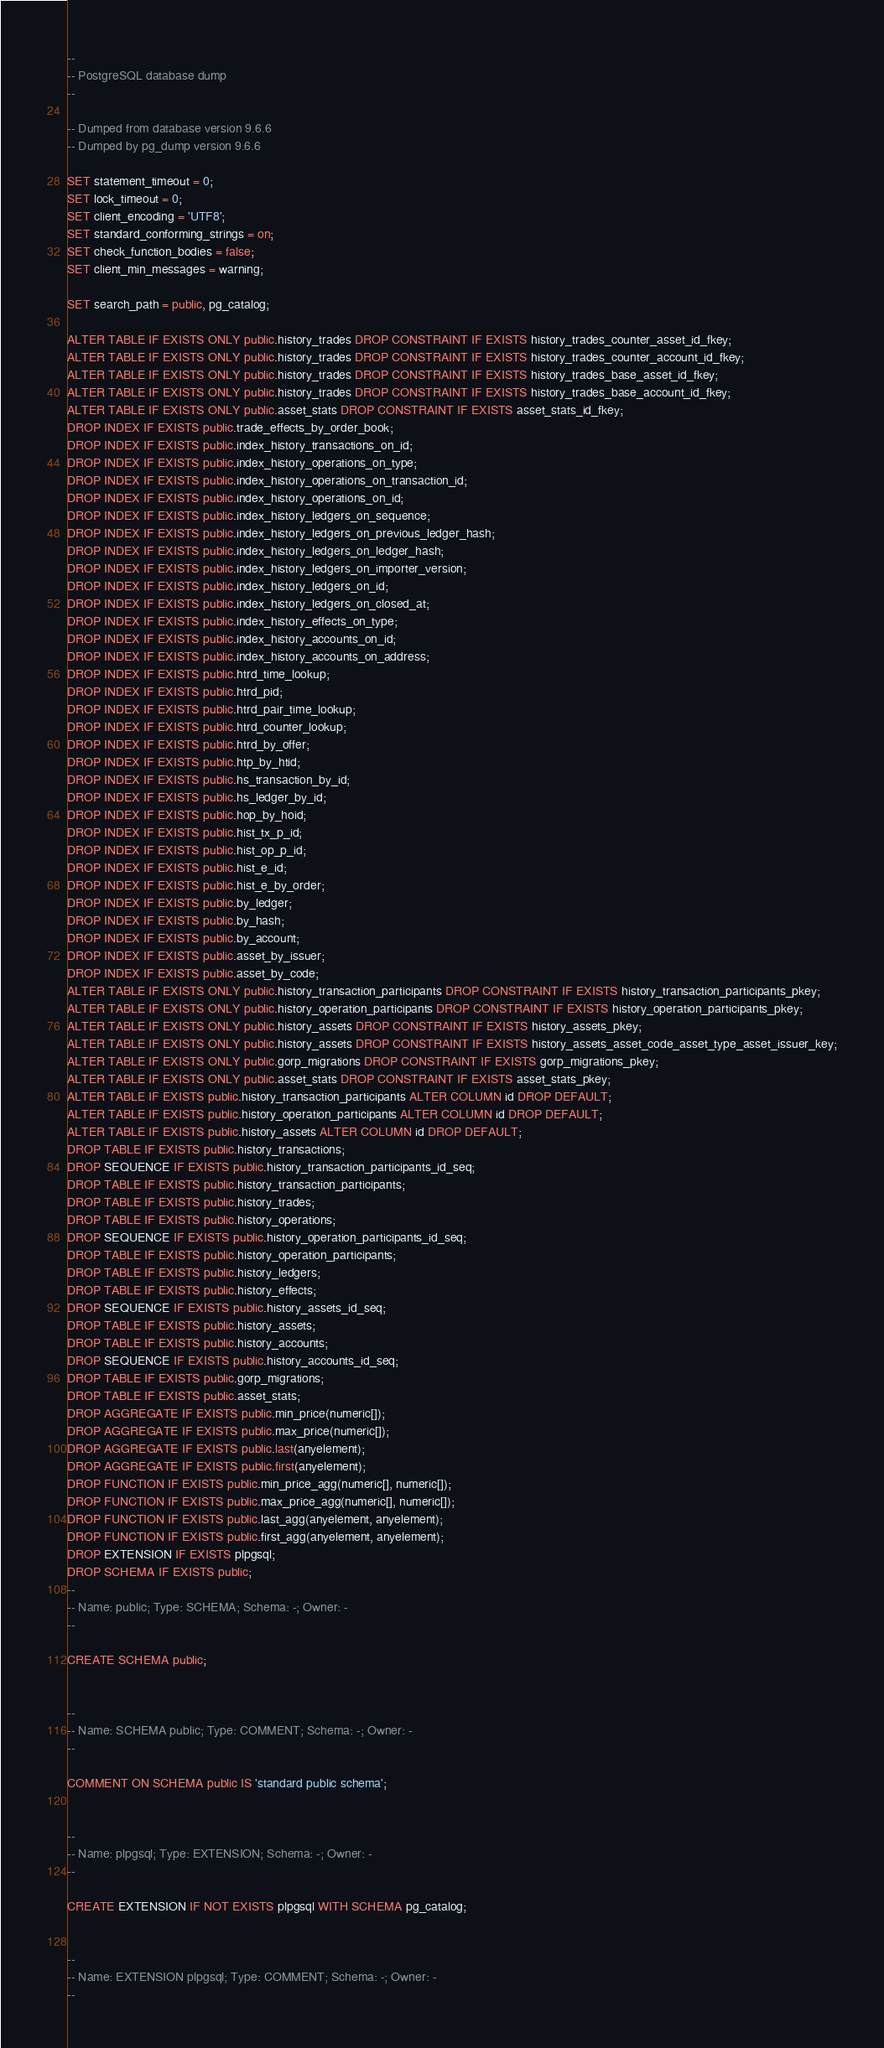<code> <loc_0><loc_0><loc_500><loc_500><_SQL_>--
-- PostgreSQL database dump
--

-- Dumped from database version 9.6.6
-- Dumped by pg_dump version 9.6.6

SET statement_timeout = 0;
SET lock_timeout = 0;
SET client_encoding = 'UTF8';
SET standard_conforming_strings = on;
SET check_function_bodies = false;
SET client_min_messages = warning;

SET search_path = public, pg_catalog;

ALTER TABLE IF EXISTS ONLY public.history_trades DROP CONSTRAINT IF EXISTS history_trades_counter_asset_id_fkey;
ALTER TABLE IF EXISTS ONLY public.history_trades DROP CONSTRAINT IF EXISTS history_trades_counter_account_id_fkey;
ALTER TABLE IF EXISTS ONLY public.history_trades DROP CONSTRAINT IF EXISTS history_trades_base_asset_id_fkey;
ALTER TABLE IF EXISTS ONLY public.history_trades DROP CONSTRAINT IF EXISTS history_trades_base_account_id_fkey;
ALTER TABLE IF EXISTS ONLY public.asset_stats DROP CONSTRAINT IF EXISTS asset_stats_id_fkey;
DROP INDEX IF EXISTS public.trade_effects_by_order_book;
DROP INDEX IF EXISTS public.index_history_transactions_on_id;
DROP INDEX IF EXISTS public.index_history_operations_on_type;
DROP INDEX IF EXISTS public.index_history_operations_on_transaction_id;
DROP INDEX IF EXISTS public.index_history_operations_on_id;
DROP INDEX IF EXISTS public.index_history_ledgers_on_sequence;
DROP INDEX IF EXISTS public.index_history_ledgers_on_previous_ledger_hash;
DROP INDEX IF EXISTS public.index_history_ledgers_on_ledger_hash;
DROP INDEX IF EXISTS public.index_history_ledgers_on_importer_version;
DROP INDEX IF EXISTS public.index_history_ledgers_on_id;
DROP INDEX IF EXISTS public.index_history_ledgers_on_closed_at;
DROP INDEX IF EXISTS public.index_history_effects_on_type;
DROP INDEX IF EXISTS public.index_history_accounts_on_id;
DROP INDEX IF EXISTS public.index_history_accounts_on_address;
DROP INDEX IF EXISTS public.htrd_time_lookup;
DROP INDEX IF EXISTS public.htrd_pid;
DROP INDEX IF EXISTS public.htrd_pair_time_lookup;
DROP INDEX IF EXISTS public.htrd_counter_lookup;
DROP INDEX IF EXISTS public.htrd_by_offer;
DROP INDEX IF EXISTS public.htp_by_htid;
DROP INDEX IF EXISTS public.hs_transaction_by_id;
DROP INDEX IF EXISTS public.hs_ledger_by_id;
DROP INDEX IF EXISTS public.hop_by_hoid;
DROP INDEX IF EXISTS public.hist_tx_p_id;
DROP INDEX IF EXISTS public.hist_op_p_id;
DROP INDEX IF EXISTS public.hist_e_id;
DROP INDEX IF EXISTS public.hist_e_by_order;
DROP INDEX IF EXISTS public.by_ledger;
DROP INDEX IF EXISTS public.by_hash;
DROP INDEX IF EXISTS public.by_account;
DROP INDEX IF EXISTS public.asset_by_issuer;
DROP INDEX IF EXISTS public.asset_by_code;
ALTER TABLE IF EXISTS ONLY public.history_transaction_participants DROP CONSTRAINT IF EXISTS history_transaction_participants_pkey;
ALTER TABLE IF EXISTS ONLY public.history_operation_participants DROP CONSTRAINT IF EXISTS history_operation_participants_pkey;
ALTER TABLE IF EXISTS ONLY public.history_assets DROP CONSTRAINT IF EXISTS history_assets_pkey;
ALTER TABLE IF EXISTS ONLY public.history_assets DROP CONSTRAINT IF EXISTS history_assets_asset_code_asset_type_asset_issuer_key;
ALTER TABLE IF EXISTS ONLY public.gorp_migrations DROP CONSTRAINT IF EXISTS gorp_migrations_pkey;
ALTER TABLE IF EXISTS ONLY public.asset_stats DROP CONSTRAINT IF EXISTS asset_stats_pkey;
ALTER TABLE IF EXISTS public.history_transaction_participants ALTER COLUMN id DROP DEFAULT;
ALTER TABLE IF EXISTS public.history_operation_participants ALTER COLUMN id DROP DEFAULT;
ALTER TABLE IF EXISTS public.history_assets ALTER COLUMN id DROP DEFAULT;
DROP TABLE IF EXISTS public.history_transactions;
DROP SEQUENCE IF EXISTS public.history_transaction_participants_id_seq;
DROP TABLE IF EXISTS public.history_transaction_participants;
DROP TABLE IF EXISTS public.history_trades;
DROP TABLE IF EXISTS public.history_operations;
DROP SEQUENCE IF EXISTS public.history_operation_participants_id_seq;
DROP TABLE IF EXISTS public.history_operation_participants;
DROP TABLE IF EXISTS public.history_ledgers;
DROP TABLE IF EXISTS public.history_effects;
DROP SEQUENCE IF EXISTS public.history_assets_id_seq;
DROP TABLE IF EXISTS public.history_assets;
DROP TABLE IF EXISTS public.history_accounts;
DROP SEQUENCE IF EXISTS public.history_accounts_id_seq;
DROP TABLE IF EXISTS public.gorp_migrations;
DROP TABLE IF EXISTS public.asset_stats;
DROP AGGREGATE IF EXISTS public.min_price(numeric[]);
DROP AGGREGATE IF EXISTS public.max_price(numeric[]);
DROP AGGREGATE IF EXISTS public.last(anyelement);
DROP AGGREGATE IF EXISTS public.first(anyelement);
DROP FUNCTION IF EXISTS public.min_price_agg(numeric[], numeric[]);
DROP FUNCTION IF EXISTS public.max_price_agg(numeric[], numeric[]);
DROP FUNCTION IF EXISTS public.last_agg(anyelement, anyelement);
DROP FUNCTION IF EXISTS public.first_agg(anyelement, anyelement);
DROP EXTENSION IF EXISTS plpgsql;
DROP SCHEMA IF EXISTS public;
--
-- Name: public; Type: SCHEMA; Schema: -; Owner: -
--

CREATE SCHEMA public;


--
-- Name: SCHEMA public; Type: COMMENT; Schema: -; Owner: -
--

COMMENT ON SCHEMA public IS 'standard public schema';


--
-- Name: plpgsql; Type: EXTENSION; Schema: -; Owner: -
--

CREATE EXTENSION IF NOT EXISTS plpgsql WITH SCHEMA pg_catalog;


--
-- Name: EXTENSION plpgsql; Type: COMMENT; Schema: -; Owner: -
--
</code> 